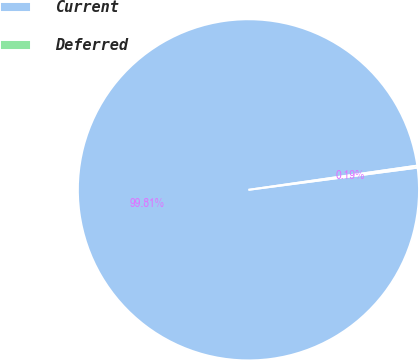Convert chart to OTSL. <chart><loc_0><loc_0><loc_500><loc_500><pie_chart><fcel>Current<fcel>Deferred<nl><fcel>99.81%<fcel>0.19%<nl></chart> 